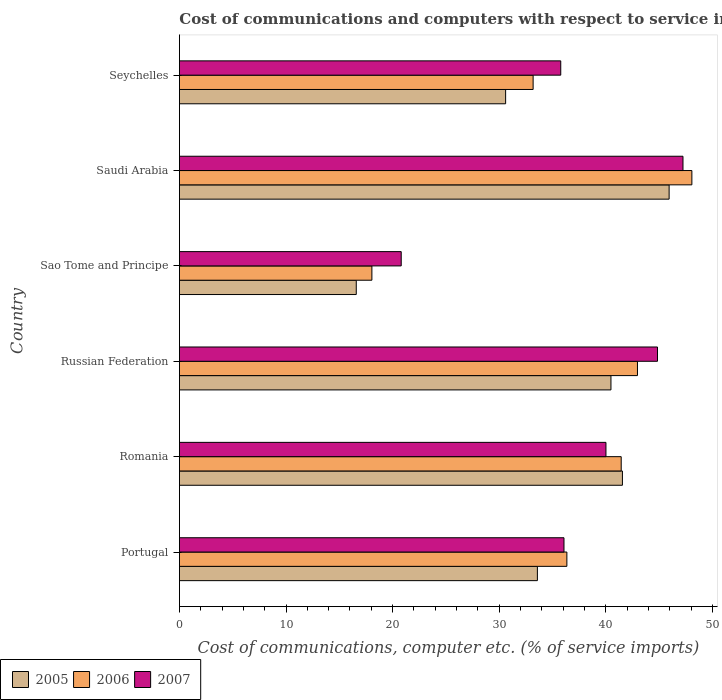How many different coloured bars are there?
Give a very brief answer. 3. How many groups of bars are there?
Ensure brevity in your answer.  6. Are the number of bars per tick equal to the number of legend labels?
Your answer should be compact. Yes. Are the number of bars on each tick of the Y-axis equal?
Provide a short and direct response. Yes. How many bars are there on the 6th tick from the top?
Your answer should be very brief. 3. How many bars are there on the 1st tick from the bottom?
Your response must be concise. 3. What is the cost of communications and computers in 2007 in Seychelles?
Offer a terse response. 35.78. Across all countries, what is the maximum cost of communications and computers in 2005?
Ensure brevity in your answer.  45.95. Across all countries, what is the minimum cost of communications and computers in 2007?
Your answer should be very brief. 20.81. In which country was the cost of communications and computers in 2005 maximum?
Your answer should be very brief. Saudi Arabia. In which country was the cost of communications and computers in 2007 minimum?
Give a very brief answer. Sao Tome and Principe. What is the total cost of communications and computers in 2006 in the graph?
Ensure brevity in your answer.  220.11. What is the difference between the cost of communications and computers in 2005 in Romania and that in Sao Tome and Principe?
Your answer should be compact. 24.97. What is the difference between the cost of communications and computers in 2007 in Saudi Arabia and the cost of communications and computers in 2005 in Seychelles?
Make the answer very short. 16.64. What is the average cost of communications and computers in 2007 per country?
Ensure brevity in your answer.  37.47. What is the difference between the cost of communications and computers in 2005 and cost of communications and computers in 2006 in Sao Tome and Principe?
Your answer should be compact. -1.47. What is the ratio of the cost of communications and computers in 2005 in Romania to that in Seychelles?
Give a very brief answer. 1.36. What is the difference between the highest and the second highest cost of communications and computers in 2006?
Your answer should be very brief. 5.1. What is the difference between the highest and the lowest cost of communications and computers in 2007?
Offer a terse response. 26.44. In how many countries, is the cost of communications and computers in 2006 greater than the average cost of communications and computers in 2006 taken over all countries?
Keep it short and to the point. 3. What does the 3rd bar from the top in Seychelles represents?
Offer a very short reply. 2005. Is it the case that in every country, the sum of the cost of communications and computers in 2006 and cost of communications and computers in 2005 is greater than the cost of communications and computers in 2007?
Your response must be concise. Yes. Are all the bars in the graph horizontal?
Provide a short and direct response. Yes. How many countries are there in the graph?
Ensure brevity in your answer.  6. Does the graph contain any zero values?
Your answer should be compact. No. Where does the legend appear in the graph?
Your response must be concise. Bottom left. How are the legend labels stacked?
Ensure brevity in your answer.  Horizontal. What is the title of the graph?
Provide a short and direct response. Cost of communications and computers with respect to service imports. Does "1961" appear as one of the legend labels in the graph?
Make the answer very short. No. What is the label or title of the X-axis?
Ensure brevity in your answer.  Cost of communications, computer etc. (% of service imports). What is the label or title of the Y-axis?
Offer a terse response. Country. What is the Cost of communications, computer etc. (% of service imports) in 2005 in Portugal?
Provide a succinct answer. 33.59. What is the Cost of communications, computer etc. (% of service imports) in 2006 in Portugal?
Your answer should be compact. 36.35. What is the Cost of communications, computer etc. (% of service imports) of 2007 in Portugal?
Offer a very short reply. 36.08. What is the Cost of communications, computer etc. (% of service imports) in 2005 in Romania?
Offer a very short reply. 41.57. What is the Cost of communications, computer etc. (% of service imports) of 2006 in Romania?
Offer a terse response. 41.45. What is the Cost of communications, computer etc. (% of service imports) in 2007 in Romania?
Keep it short and to the point. 40.02. What is the Cost of communications, computer etc. (% of service imports) in 2005 in Russian Federation?
Provide a short and direct response. 40.49. What is the Cost of communications, computer etc. (% of service imports) of 2006 in Russian Federation?
Provide a succinct answer. 42.98. What is the Cost of communications, computer etc. (% of service imports) of 2007 in Russian Federation?
Provide a short and direct response. 44.86. What is the Cost of communications, computer etc. (% of service imports) of 2005 in Sao Tome and Principe?
Your answer should be very brief. 16.59. What is the Cost of communications, computer etc. (% of service imports) in 2006 in Sao Tome and Principe?
Your response must be concise. 18.06. What is the Cost of communications, computer etc. (% of service imports) in 2007 in Sao Tome and Principe?
Offer a terse response. 20.81. What is the Cost of communications, computer etc. (% of service imports) in 2005 in Saudi Arabia?
Offer a terse response. 45.95. What is the Cost of communications, computer etc. (% of service imports) of 2006 in Saudi Arabia?
Offer a very short reply. 48.08. What is the Cost of communications, computer etc. (% of service imports) in 2007 in Saudi Arabia?
Your response must be concise. 47.25. What is the Cost of communications, computer etc. (% of service imports) in 2005 in Seychelles?
Make the answer very short. 30.61. What is the Cost of communications, computer etc. (% of service imports) of 2006 in Seychelles?
Make the answer very short. 33.19. What is the Cost of communications, computer etc. (% of service imports) in 2007 in Seychelles?
Make the answer very short. 35.78. Across all countries, what is the maximum Cost of communications, computer etc. (% of service imports) in 2005?
Your response must be concise. 45.95. Across all countries, what is the maximum Cost of communications, computer etc. (% of service imports) of 2006?
Offer a very short reply. 48.08. Across all countries, what is the maximum Cost of communications, computer etc. (% of service imports) in 2007?
Give a very brief answer. 47.25. Across all countries, what is the minimum Cost of communications, computer etc. (% of service imports) of 2005?
Offer a terse response. 16.59. Across all countries, what is the minimum Cost of communications, computer etc. (% of service imports) in 2006?
Offer a terse response. 18.06. Across all countries, what is the minimum Cost of communications, computer etc. (% of service imports) in 2007?
Give a very brief answer. 20.81. What is the total Cost of communications, computer etc. (% of service imports) of 2005 in the graph?
Offer a terse response. 208.79. What is the total Cost of communications, computer etc. (% of service imports) of 2006 in the graph?
Make the answer very short. 220.11. What is the total Cost of communications, computer etc. (% of service imports) of 2007 in the graph?
Your answer should be compact. 224.8. What is the difference between the Cost of communications, computer etc. (% of service imports) of 2005 in Portugal and that in Romania?
Your answer should be compact. -7.98. What is the difference between the Cost of communications, computer etc. (% of service imports) in 2006 in Portugal and that in Romania?
Offer a very short reply. -5.1. What is the difference between the Cost of communications, computer etc. (% of service imports) of 2007 in Portugal and that in Romania?
Your answer should be very brief. -3.94. What is the difference between the Cost of communications, computer etc. (% of service imports) of 2005 in Portugal and that in Russian Federation?
Your answer should be compact. -6.9. What is the difference between the Cost of communications, computer etc. (% of service imports) of 2006 in Portugal and that in Russian Federation?
Provide a succinct answer. -6.62. What is the difference between the Cost of communications, computer etc. (% of service imports) in 2007 in Portugal and that in Russian Federation?
Offer a terse response. -8.77. What is the difference between the Cost of communications, computer etc. (% of service imports) in 2005 in Portugal and that in Sao Tome and Principe?
Provide a short and direct response. 16.99. What is the difference between the Cost of communications, computer etc. (% of service imports) of 2006 in Portugal and that in Sao Tome and Principe?
Your answer should be very brief. 18.29. What is the difference between the Cost of communications, computer etc. (% of service imports) in 2007 in Portugal and that in Sao Tome and Principe?
Provide a short and direct response. 15.27. What is the difference between the Cost of communications, computer etc. (% of service imports) in 2005 in Portugal and that in Saudi Arabia?
Your response must be concise. -12.36. What is the difference between the Cost of communications, computer etc. (% of service imports) in 2006 in Portugal and that in Saudi Arabia?
Ensure brevity in your answer.  -11.73. What is the difference between the Cost of communications, computer etc. (% of service imports) of 2007 in Portugal and that in Saudi Arabia?
Offer a terse response. -11.16. What is the difference between the Cost of communications, computer etc. (% of service imports) in 2005 in Portugal and that in Seychelles?
Make the answer very short. 2.98. What is the difference between the Cost of communications, computer etc. (% of service imports) in 2006 in Portugal and that in Seychelles?
Make the answer very short. 3.17. What is the difference between the Cost of communications, computer etc. (% of service imports) of 2007 in Portugal and that in Seychelles?
Your answer should be very brief. 0.3. What is the difference between the Cost of communications, computer etc. (% of service imports) of 2005 in Romania and that in Russian Federation?
Offer a very short reply. 1.08. What is the difference between the Cost of communications, computer etc. (% of service imports) of 2006 in Romania and that in Russian Federation?
Give a very brief answer. -1.53. What is the difference between the Cost of communications, computer etc. (% of service imports) of 2007 in Romania and that in Russian Federation?
Give a very brief answer. -4.84. What is the difference between the Cost of communications, computer etc. (% of service imports) of 2005 in Romania and that in Sao Tome and Principe?
Offer a terse response. 24.97. What is the difference between the Cost of communications, computer etc. (% of service imports) in 2006 in Romania and that in Sao Tome and Principe?
Provide a succinct answer. 23.39. What is the difference between the Cost of communications, computer etc. (% of service imports) in 2007 in Romania and that in Sao Tome and Principe?
Keep it short and to the point. 19.21. What is the difference between the Cost of communications, computer etc. (% of service imports) of 2005 in Romania and that in Saudi Arabia?
Your answer should be compact. -4.38. What is the difference between the Cost of communications, computer etc. (% of service imports) of 2006 in Romania and that in Saudi Arabia?
Provide a short and direct response. -6.63. What is the difference between the Cost of communications, computer etc. (% of service imports) in 2007 in Romania and that in Saudi Arabia?
Keep it short and to the point. -7.23. What is the difference between the Cost of communications, computer etc. (% of service imports) of 2005 in Romania and that in Seychelles?
Give a very brief answer. 10.96. What is the difference between the Cost of communications, computer etc. (% of service imports) in 2006 in Romania and that in Seychelles?
Provide a succinct answer. 8.27. What is the difference between the Cost of communications, computer etc. (% of service imports) in 2007 in Romania and that in Seychelles?
Give a very brief answer. 4.24. What is the difference between the Cost of communications, computer etc. (% of service imports) in 2005 in Russian Federation and that in Sao Tome and Principe?
Your answer should be compact. 23.9. What is the difference between the Cost of communications, computer etc. (% of service imports) in 2006 in Russian Federation and that in Sao Tome and Principe?
Your answer should be compact. 24.92. What is the difference between the Cost of communications, computer etc. (% of service imports) of 2007 in Russian Federation and that in Sao Tome and Principe?
Ensure brevity in your answer.  24.05. What is the difference between the Cost of communications, computer etc. (% of service imports) of 2005 in Russian Federation and that in Saudi Arabia?
Make the answer very short. -5.46. What is the difference between the Cost of communications, computer etc. (% of service imports) of 2006 in Russian Federation and that in Saudi Arabia?
Offer a terse response. -5.1. What is the difference between the Cost of communications, computer etc. (% of service imports) of 2007 in Russian Federation and that in Saudi Arabia?
Offer a very short reply. -2.39. What is the difference between the Cost of communications, computer etc. (% of service imports) of 2005 in Russian Federation and that in Seychelles?
Your answer should be compact. 9.88. What is the difference between the Cost of communications, computer etc. (% of service imports) in 2006 in Russian Federation and that in Seychelles?
Give a very brief answer. 9.79. What is the difference between the Cost of communications, computer etc. (% of service imports) in 2007 in Russian Federation and that in Seychelles?
Make the answer very short. 9.08. What is the difference between the Cost of communications, computer etc. (% of service imports) of 2005 in Sao Tome and Principe and that in Saudi Arabia?
Make the answer very short. -29.35. What is the difference between the Cost of communications, computer etc. (% of service imports) in 2006 in Sao Tome and Principe and that in Saudi Arabia?
Provide a succinct answer. -30.02. What is the difference between the Cost of communications, computer etc. (% of service imports) in 2007 in Sao Tome and Principe and that in Saudi Arabia?
Your response must be concise. -26.44. What is the difference between the Cost of communications, computer etc. (% of service imports) in 2005 in Sao Tome and Principe and that in Seychelles?
Ensure brevity in your answer.  -14.01. What is the difference between the Cost of communications, computer etc. (% of service imports) of 2006 in Sao Tome and Principe and that in Seychelles?
Keep it short and to the point. -15.13. What is the difference between the Cost of communications, computer etc. (% of service imports) of 2007 in Sao Tome and Principe and that in Seychelles?
Ensure brevity in your answer.  -14.97. What is the difference between the Cost of communications, computer etc. (% of service imports) of 2005 in Saudi Arabia and that in Seychelles?
Provide a short and direct response. 15.34. What is the difference between the Cost of communications, computer etc. (% of service imports) in 2006 in Saudi Arabia and that in Seychelles?
Your response must be concise. 14.9. What is the difference between the Cost of communications, computer etc. (% of service imports) of 2007 in Saudi Arabia and that in Seychelles?
Offer a very short reply. 11.47. What is the difference between the Cost of communications, computer etc. (% of service imports) of 2005 in Portugal and the Cost of communications, computer etc. (% of service imports) of 2006 in Romania?
Offer a very short reply. -7.86. What is the difference between the Cost of communications, computer etc. (% of service imports) in 2005 in Portugal and the Cost of communications, computer etc. (% of service imports) in 2007 in Romania?
Offer a very short reply. -6.43. What is the difference between the Cost of communications, computer etc. (% of service imports) of 2006 in Portugal and the Cost of communications, computer etc. (% of service imports) of 2007 in Romania?
Give a very brief answer. -3.67. What is the difference between the Cost of communications, computer etc. (% of service imports) in 2005 in Portugal and the Cost of communications, computer etc. (% of service imports) in 2006 in Russian Federation?
Provide a succinct answer. -9.39. What is the difference between the Cost of communications, computer etc. (% of service imports) of 2005 in Portugal and the Cost of communications, computer etc. (% of service imports) of 2007 in Russian Federation?
Offer a very short reply. -11.27. What is the difference between the Cost of communications, computer etc. (% of service imports) of 2006 in Portugal and the Cost of communications, computer etc. (% of service imports) of 2007 in Russian Federation?
Offer a very short reply. -8.5. What is the difference between the Cost of communications, computer etc. (% of service imports) of 2005 in Portugal and the Cost of communications, computer etc. (% of service imports) of 2006 in Sao Tome and Principe?
Provide a short and direct response. 15.53. What is the difference between the Cost of communications, computer etc. (% of service imports) of 2005 in Portugal and the Cost of communications, computer etc. (% of service imports) of 2007 in Sao Tome and Principe?
Make the answer very short. 12.78. What is the difference between the Cost of communications, computer etc. (% of service imports) of 2006 in Portugal and the Cost of communications, computer etc. (% of service imports) of 2007 in Sao Tome and Principe?
Give a very brief answer. 15.54. What is the difference between the Cost of communications, computer etc. (% of service imports) in 2005 in Portugal and the Cost of communications, computer etc. (% of service imports) in 2006 in Saudi Arabia?
Offer a terse response. -14.49. What is the difference between the Cost of communications, computer etc. (% of service imports) in 2005 in Portugal and the Cost of communications, computer etc. (% of service imports) in 2007 in Saudi Arabia?
Provide a succinct answer. -13.66. What is the difference between the Cost of communications, computer etc. (% of service imports) in 2006 in Portugal and the Cost of communications, computer etc. (% of service imports) in 2007 in Saudi Arabia?
Provide a succinct answer. -10.89. What is the difference between the Cost of communications, computer etc. (% of service imports) in 2005 in Portugal and the Cost of communications, computer etc. (% of service imports) in 2006 in Seychelles?
Provide a short and direct response. 0.4. What is the difference between the Cost of communications, computer etc. (% of service imports) of 2005 in Portugal and the Cost of communications, computer etc. (% of service imports) of 2007 in Seychelles?
Your answer should be very brief. -2.19. What is the difference between the Cost of communications, computer etc. (% of service imports) in 2006 in Portugal and the Cost of communications, computer etc. (% of service imports) in 2007 in Seychelles?
Your answer should be compact. 0.57. What is the difference between the Cost of communications, computer etc. (% of service imports) in 2005 in Romania and the Cost of communications, computer etc. (% of service imports) in 2006 in Russian Federation?
Provide a short and direct response. -1.41. What is the difference between the Cost of communications, computer etc. (% of service imports) of 2005 in Romania and the Cost of communications, computer etc. (% of service imports) of 2007 in Russian Federation?
Your answer should be very brief. -3.29. What is the difference between the Cost of communications, computer etc. (% of service imports) in 2006 in Romania and the Cost of communications, computer etc. (% of service imports) in 2007 in Russian Federation?
Your answer should be very brief. -3.4. What is the difference between the Cost of communications, computer etc. (% of service imports) of 2005 in Romania and the Cost of communications, computer etc. (% of service imports) of 2006 in Sao Tome and Principe?
Make the answer very short. 23.51. What is the difference between the Cost of communications, computer etc. (% of service imports) in 2005 in Romania and the Cost of communications, computer etc. (% of service imports) in 2007 in Sao Tome and Principe?
Your answer should be very brief. 20.76. What is the difference between the Cost of communications, computer etc. (% of service imports) of 2006 in Romania and the Cost of communications, computer etc. (% of service imports) of 2007 in Sao Tome and Principe?
Your answer should be very brief. 20.64. What is the difference between the Cost of communications, computer etc. (% of service imports) of 2005 in Romania and the Cost of communications, computer etc. (% of service imports) of 2006 in Saudi Arabia?
Ensure brevity in your answer.  -6.52. What is the difference between the Cost of communications, computer etc. (% of service imports) of 2005 in Romania and the Cost of communications, computer etc. (% of service imports) of 2007 in Saudi Arabia?
Provide a short and direct response. -5.68. What is the difference between the Cost of communications, computer etc. (% of service imports) of 2006 in Romania and the Cost of communications, computer etc. (% of service imports) of 2007 in Saudi Arabia?
Provide a succinct answer. -5.8. What is the difference between the Cost of communications, computer etc. (% of service imports) of 2005 in Romania and the Cost of communications, computer etc. (% of service imports) of 2006 in Seychelles?
Offer a terse response. 8.38. What is the difference between the Cost of communications, computer etc. (% of service imports) in 2005 in Romania and the Cost of communications, computer etc. (% of service imports) in 2007 in Seychelles?
Give a very brief answer. 5.79. What is the difference between the Cost of communications, computer etc. (% of service imports) in 2006 in Romania and the Cost of communications, computer etc. (% of service imports) in 2007 in Seychelles?
Provide a succinct answer. 5.67. What is the difference between the Cost of communications, computer etc. (% of service imports) of 2005 in Russian Federation and the Cost of communications, computer etc. (% of service imports) of 2006 in Sao Tome and Principe?
Keep it short and to the point. 22.43. What is the difference between the Cost of communications, computer etc. (% of service imports) in 2005 in Russian Federation and the Cost of communications, computer etc. (% of service imports) in 2007 in Sao Tome and Principe?
Ensure brevity in your answer.  19.68. What is the difference between the Cost of communications, computer etc. (% of service imports) in 2006 in Russian Federation and the Cost of communications, computer etc. (% of service imports) in 2007 in Sao Tome and Principe?
Ensure brevity in your answer.  22.17. What is the difference between the Cost of communications, computer etc. (% of service imports) in 2005 in Russian Federation and the Cost of communications, computer etc. (% of service imports) in 2006 in Saudi Arabia?
Make the answer very short. -7.59. What is the difference between the Cost of communications, computer etc. (% of service imports) of 2005 in Russian Federation and the Cost of communications, computer etc. (% of service imports) of 2007 in Saudi Arabia?
Your answer should be compact. -6.76. What is the difference between the Cost of communications, computer etc. (% of service imports) in 2006 in Russian Federation and the Cost of communications, computer etc. (% of service imports) in 2007 in Saudi Arabia?
Offer a terse response. -4.27. What is the difference between the Cost of communications, computer etc. (% of service imports) of 2005 in Russian Federation and the Cost of communications, computer etc. (% of service imports) of 2006 in Seychelles?
Your response must be concise. 7.3. What is the difference between the Cost of communications, computer etc. (% of service imports) in 2005 in Russian Federation and the Cost of communications, computer etc. (% of service imports) in 2007 in Seychelles?
Offer a terse response. 4.71. What is the difference between the Cost of communications, computer etc. (% of service imports) of 2006 in Russian Federation and the Cost of communications, computer etc. (% of service imports) of 2007 in Seychelles?
Provide a succinct answer. 7.2. What is the difference between the Cost of communications, computer etc. (% of service imports) of 2005 in Sao Tome and Principe and the Cost of communications, computer etc. (% of service imports) of 2006 in Saudi Arabia?
Your answer should be very brief. -31.49. What is the difference between the Cost of communications, computer etc. (% of service imports) in 2005 in Sao Tome and Principe and the Cost of communications, computer etc. (% of service imports) in 2007 in Saudi Arabia?
Offer a terse response. -30.65. What is the difference between the Cost of communications, computer etc. (% of service imports) in 2006 in Sao Tome and Principe and the Cost of communications, computer etc. (% of service imports) in 2007 in Saudi Arabia?
Provide a short and direct response. -29.19. What is the difference between the Cost of communications, computer etc. (% of service imports) of 2005 in Sao Tome and Principe and the Cost of communications, computer etc. (% of service imports) of 2006 in Seychelles?
Ensure brevity in your answer.  -16.59. What is the difference between the Cost of communications, computer etc. (% of service imports) of 2005 in Sao Tome and Principe and the Cost of communications, computer etc. (% of service imports) of 2007 in Seychelles?
Give a very brief answer. -19.19. What is the difference between the Cost of communications, computer etc. (% of service imports) in 2006 in Sao Tome and Principe and the Cost of communications, computer etc. (% of service imports) in 2007 in Seychelles?
Provide a short and direct response. -17.72. What is the difference between the Cost of communications, computer etc. (% of service imports) in 2005 in Saudi Arabia and the Cost of communications, computer etc. (% of service imports) in 2006 in Seychelles?
Your response must be concise. 12.76. What is the difference between the Cost of communications, computer etc. (% of service imports) in 2005 in Saudi Arabia and the Cost of communications, computer etc. (% of service imports) in 2007 in Seychelles?
Keep it short and to the point. 10.17. What is the difference between the Cost of communications, computer etc. (% of service imports) in 2006 in Saudi Arabia and the Cost of communications, computer etc. (% of service imports) in 2007 in Seychelles?
Your response must be concise. 12.3. What is the average Cost of communications, computer etc. (% of service imports) in 2005 per country?
Offer a terse response. 34.8. What is the average Cost of communications, computer etc. (% of service imports) of 2006 per country?
Your answer should be compact. 36.69. What is the average Cost of communications, computer etc. (% of service imports) in 2007 per country?
Make the answer very short. 37.47. What is the difference between the Cost of communications, computer etc. (% of service imports) of 2005 and Cost of communications, computer etc. (% of service imports) of 2006 in Portugal?
Your answer should be very brief. -2.77. What is the difference between the Cost of communications, computer etc. (% of service imports) in 2005 and Cost of communications, computer etc. (% of service imports) in 2007 in Portugal?
Offer a terse response. -2.5. What is the difference between the Cost of communications, computer etc. (% of service imports) of 2006 and Cost of communications, computer etc. (% of service imports) of 2007 in Portugal?
Provide a succinct answer. 0.27. What is the difference between the Cost of communications, computer etc. (% of service imports) of 2005 and Cost of communications, computer etc. (% of service imports) of 2006 in Romania?
Offer a terse response. 0.11. What is the difference between the Cost of communications, computer etc. (% of service imports) in 2005 and Cost of communications, computer etc. (% of service imports) in 2007 in Romania?
Give a very brief answer. 1.55. What is the difference between the Cost of communications, computer etc. (% of service imports) in 2006 and Cost of communications, computer etc. (% of service imports) in 2007 in Romania?
Ensure brevity in your answer.  1.43. What is the difference between the Cost of communications, computer etc. (% of service imports) in 2005 and Cost of communications, computer etc. (% of service imports) in 2006 in Russian Federation?
Keep it short and to the point. -2.49. What is the difference between the Cost of communications, computer etc. (% of service imports) in 2005 and Cost of communications, computer etc. (% of service imports) in 2007 in Russian Federation?
Your answer should be compact. -4.37. What is the difference between the Cost of communications, computer etc. (% of service imports) in 2006 and Cost of communications, computer etc. (% of service imports) in 2007 in Russian Federation?
Provide a succinct answer. -1.88. What is the difference between the Cost of communications, computer etc. (% of service imports) in 2005 and Cost of communications, computer etc. (% of service imports) in 2006 in Sao Tome and Principe?
Provide a succinct answer. -1.47. What is the difference between the Cost of communications, computer etc. (% of service imports) in 2005 and Cost of communications, computer etc. (% of service imports) in 2007 in Sao Tome and Principe?
Your answer should be very brief. -4.22. What is the difference between the Cost of communications, computer etc. (% of service imports) in 2006 and Cost of communications, computer etc. (% of service imports) in 2007 in Sao Tome and Principe?
Your answer should be very brief. -2.75. What is the difference between the Cost of communications, computer etc. (% of service imports) in 2005 and Cost of communications, computer etc. (% of service imports) in 2006 in Saudi Arabia?
Make the answer very short. -2.13. What is the difference between the Cost of communications, computer etc. (% of service imports) of 2005 and Cost of communications, computer etc. (% of service imports) of 2007 in Saudi Arabia?
Your answer should be very brief. -1.3. What is the difference between the Cost of communications, computer etc. (% of service imports) in 2006 and Cost of communications, computer etc. (% of service imports) in 2007 in Saudi Arabia?
Ensure brevity in your answer.  0.83. What is the difference between the Cost of communications, computer etc. (% of service imports) of 2005 and Cost of communications, computer etc. (% of service imports) of 2006 in Seychelles?
Your response must be concise. -2.58. What is the difference between the Cost of communications, computer etc. (% of service imports) of 2005 and Cost of communications, computer etc. (% of service imports) of 2007 in Seychelles?
Ensure brevity in your answer.  -5.17. What is the difference between the Cost of communications, computer etc. (% of service imports) in 2006 and Cost of communications, computer etc. (% of service imports) in 2007 in Seychelles?
Your answer should be compact. -2.59. What is the ratio of the Cost of communications, computer etc. (% of service imports) in 2005 in Portugal to that in Romania?
Provide a short and direct response. 0.81. What is the ratio of the Cost of communications, computer etc. (% of service imports) in 2006 in Portugal to that in Romania?
Offer a very short reply. 0.88. What is the ratio of the Cost of communications, computer etc. (% of service imports) of 2007 in Portugal to that in Romania?
Make the answer very short. 0.9. What is the ratio of the Cost of communications, computer etc. (% of service imports) of 2005 in Portugal to that in Russian Federation?
Your answer should be compact. 0.83. What is the ratio of the Cost of communications, computer etc. (% of service imports) in 2006 in Portugal to that in Russian Federation?
Offer a very short reply. 0.85. What is the ratio of the Cost of communications, computer etc. (% of service imports) of 2007 in Portugal to that in Russian Federation?
Make the answer very short. 0.8. What is the ratio of the Cost of communications, computer etc. (% of service imports) of 2005 in Portugal to that in Sao Tome and Principe?
Keep it short and to the point. 2.02. What is the ratio of the Cost of communications, computer etc. (% of service imports) of 2006 in Portugal to that in Sao Tome and Principe?
Ensure brevity in your answer.  2.01. What is the ratio of the Cost of communications, computer etc. (% of service imports) in 2007 in Portugal to that in Sao Tome and Principe?
Your response must be concise. 1.73. What is the ratio of the Cost of communications, computer etc. (% of service imports) of 2005 in Portugal to that in Saudi Arabia?
Ensure brevity in your answer.  0.73. What is the ratio of the Cost of communications, computer etc. (% of service imports) of 2006 in Portugal to that in Saudi Arabia?
Provide a succinct answer. 0.76. What is the ratio of the Cost of communications, computer etc. (% of service imports) of 2007 in Portugal to that in Saudi Arabia?
Keep it short and to the point. 0.76. What is the ratio of the Cost of communications, computer etc. (% of service imports) in 2005 in Portugal to that in Seychelles?
Your answer should be compact. 1.1. What is the ratio of the Cost of communications, computer etc. (% of service imports) in 2006 in Portugal to that in Seychelles?
Provide a succinct answer. 1.1. What is the ratio of the Cost of communications, computer etc. (% of service imports) of 2007 in Portugal to that in Seychelles?
Your response must be concise. 1.01. What is the ratio of the Cost of communications, computer etc. (% of service imports) in 2005 in Romania to that in Russian Federation?
Your response must be concise. 1.03. What is the ratio of the Cost of communications, computer etc. (% of service imports) of 2006 in Romania to that in Russian Federation?
Your answer should be very brief. 0.96. What is the ratio of the Cost of communications, computer etc. (% of service imports) of 2007 in Romania to that in Russian Federation?
Keep it short and to the point. 0.89. What is the ratio of the Cost of communications, computer etc. (% of service imports) in 2005 in Romania to that in Sao Tome and Principe?
Provide a succinct answer. 2.5. What is the ratio of the Cost of communications, computer etc. (% of service imports) of 2006 in Romania to that in Sao Tome and Principe?
Provide a short and direct response. 2.3. What is the ratio of the Cost of communications, computer etc. (% of service imports) in 2007 in Romania to that in Sao Tome and Principe?
Offer a very short reply. 1.92. What is the ratio of the Cost of communications, computer etc. (% of service imports) in 2005 in Romania to that in Saudi Arabia?
Keep it short and to the point. 0.9. What is the ratio of the Cost of communications, computer etc. (% of service imports) in 2006 in Romania to that in Saudi Arabia?
Your response must be concise. 0.86. What is the ratio of the Cost of communications, computer etc. (% of service imports) in 2007 in Romania to that in Saudi Arabia?
Ensure brevity in your answer.  0.85. What is the ratio of the Cost of communications, computer etc. (% of service imports) in 2005 in Romania to that in Seychelles?
Your response must be concise. 1.36. What is the ratio of the Cost of communications, computer etc. (% of service imports) in 2006 in Romania to that in Seychelles?
Your answer should be compact. 1.25. What is the ratio of the Cost of communications, computer etc. (% of service imports) in 2007 in Romania to that in Seychelles?
Your answer should be very brief. 1.12. What is the ratio of the Cost of communications, computer etc. (% of service imports) of 2005 in Russian Federation to that in Sao Tome and Principe?
Your answer should be very brief. 2.44. What is the ratio of the Cost of communications, computer etc. (% of service imports) of 2006 in Russian Federation to that in Sao Tome and Principe?
Give a very brief answer. 2.38. What is the ratio of the Cost of communications, computer etc. (% of service imports) of 2007 in Russian Federation to that in Sao Tome and Principe?
Give a very brief answer. 2.16. What is the ratio of the Cost of communications, computer etc. (% of service imports) in 2005 in Russian Federation to that in Saudi Arabia?
Offer a very short reply. 0.88. What is the ratio of the Cost of communications, computer etc. (% of service imports) of 2006 in Russian Federation to that in Saudi Arabia?
Offer a very short reply. 0.89. What is the ratio of the Cost of communications, computer etc. (% of service imports) in 2007 in Russian Federation to that in Saudi Arabia?
Keep it short and to the point. 0.95. What is the ratio of the Cost of communications, computer etc. (% of service imports) in 2005 in Russian Federation to that in Seychelles?
Your response must be concise. 1.32. What is the ratio of the Cost of communications, computer etc. (% of service imports) of 2006 in Russian Federation to that in Seychelles?
Provide a succinct answer. 1.29. What is the ratio of the Cost of communications, computer etc. (% of service imports) in 2007 in Russian Federation to that in Seychelles?
Make the answer very short. 1.25. What is the ratio of the Cost of communications, computer etc. (% of service imports) in 2005 in Sao Tome and Principe to that in Saudi Arabia?
Your answer should be very brief. 0.36. What is the ratio of the Cost of communications, computer etc. (% of service imports) in 2006 in Sao Tome and Principe to that in Saudi Arabia?
Provide a succinct answer. 0.38. What is the ratio of the Cost of communications, computer etc. (% of service imports) of 2007 in Sao Tome and Principe to that in Saudi Arabia?
Offer a very short reply. 0.44. What is the ratio of the Cost of communications, computer etc. (% of service imports) in 2005 in Sao Tome and Principe to that in Seychelles?
Your answer should be very brief. 0.54. What is the ratio of the Cost of communications, computer etc. (% of service imports) of 2006 in Sao Tome and Principe to that in Seychelles?
Ensure brevity in your answer.  0.54. What is the ratio of the Cost of communications, computer etc. (% of service imports) of 2007 in Sao Tome and Principe to that in Seychelles?
Provide a short and direct response. 0.58. What is the ratio of the Cost of communications, computer etc. (% of service imports) in 2005 in Saudi Arabia to that in Seychelles?
Provide a succinct answer. 1.5. What is the ratio of the Cost of communications, computer etc. (% of service imports) in 2006 in Saudi Arabia to that in Seychelles?
Your answer should be very brief. 1.45. What is the ratio of the Cost of communications, computer etc. (% of service imports) of 2007 in Saudi Arabia to that in Seychelles?
Offer a terse response. 1.32. What is the difference between the highest and the second highest Cost of communications, computer etc. (% of service imports) in 2005?
Provide a succinct answer. 4.38. What is the difference between the highest and the second highest Cost of communications, computer etc. (% of service imports) in 2006?
Provide a succinct answer. 5.1. What is the difference between the highest and the second highest Cost of communications, computer etc. (% of service imports) of 2007?
Keep it short and to the point. 2.39. What is the difference between the highest and the lowest Cost of communications, computer etc. (% of service imports) of 2005?
Make the answer very short. 29.35. What is the difference between the highest and the lowest Cost of communications, computer etc. (% of service imports) in 2006?
Offer a terse response. 30.02. What is the difference between the highest and the lowest Cost of communications, computer etc. (% of service imports) in 2007?
Keep it short and to the point. 26.44. 